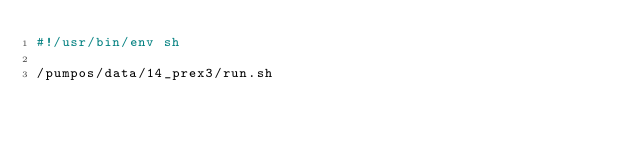Convert code to text. <code><loc_0><loc_0><loc_500><loc_500><_Bash_>#!/usr/bin/env sh

/pumpos/data/14_prex3/run.sh
</code> 